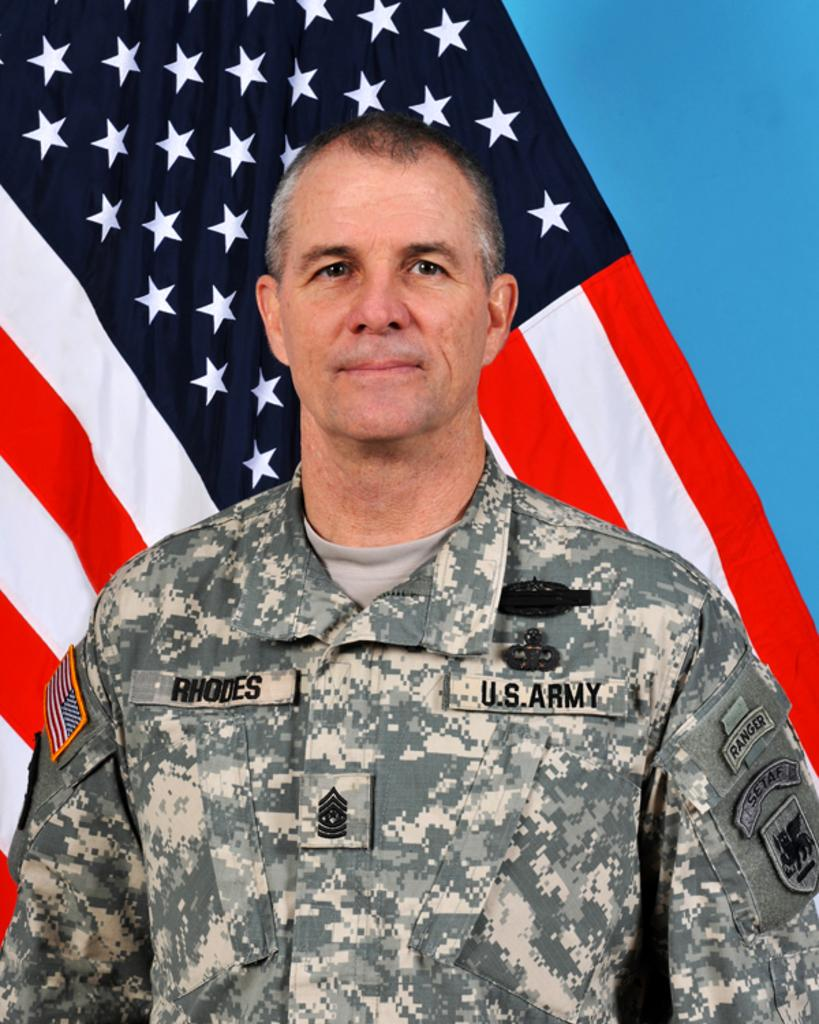Who is present in the image? There is a man in the image. What is the man wearing? The man is wearing a uniform. What can be seen in the background of the image? There is a flag in the background of the image, and the background includes blue color. How many pigs are present in the image? There are no pigs present in the image. Does the man in the image express any regret? The image does not convey any emotions or expressions, so it cannot be determined if the man expresses regret. 